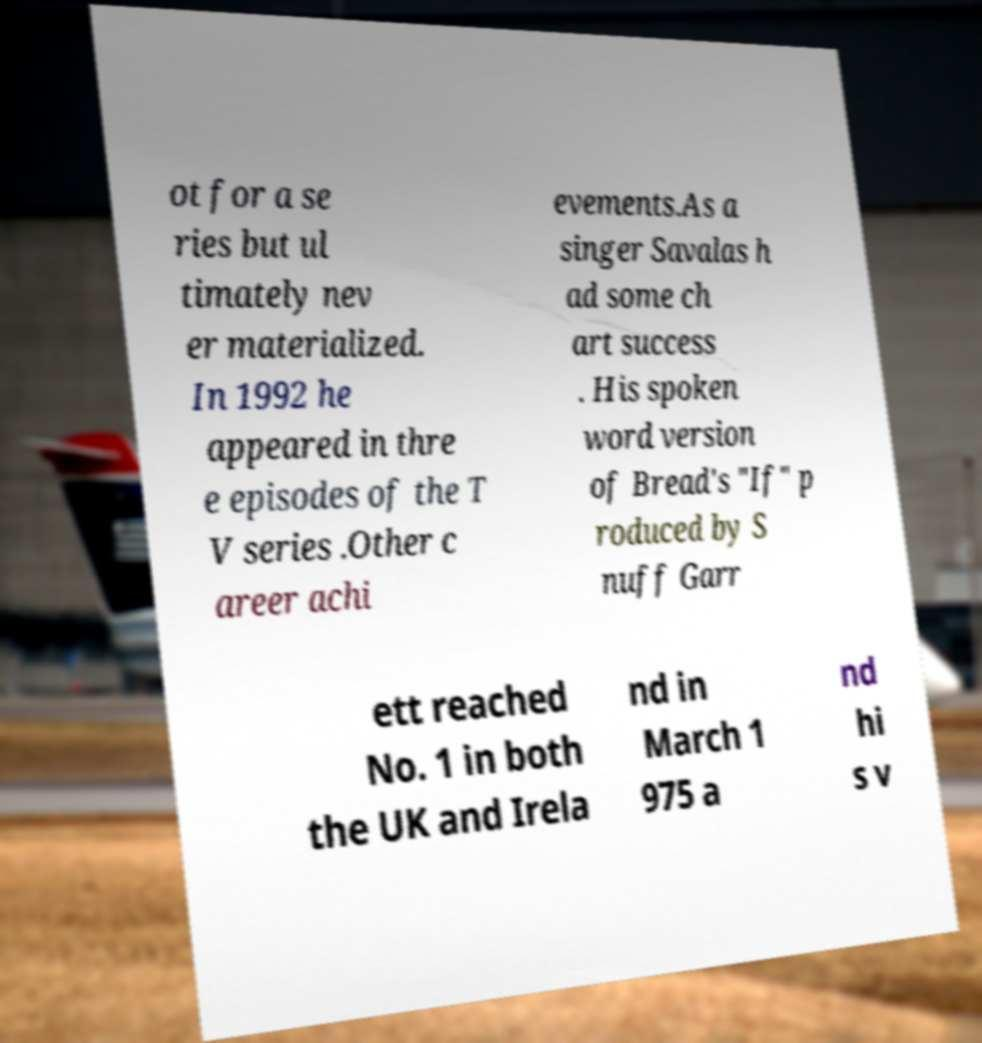There's text embedded in this image that I need extracted. Can you transcribe it verbatim? ot for a se ries but ul timately nev er materialized. In 1992 he appeared in thre e episodes of the T V series .Other c areer achi evements.As a singer Savalas h ad some ch art success . His spoken word version of Bread's "If" p roduced by S nuff Garr ett reached No. 1 in both the UK and Irela nd in March 1 975 a nd hi s v 